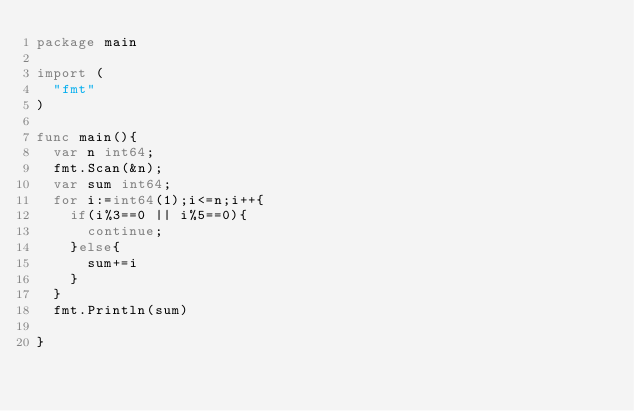<code> <loc_0><loc_0><loc_500><loc_500><_Go_>package main

import (
  "fmt"
)

func main(){
  var n int64;
  fmt.Scan(&n);
  var sum int64;
  for i:=int64(1);i<=n;i++{
    if(i%3==0 || i%5==0){
    	continue;
    }else{
    	sum+=i
    }
  }
  fmt.Println(sum)

}</code> 